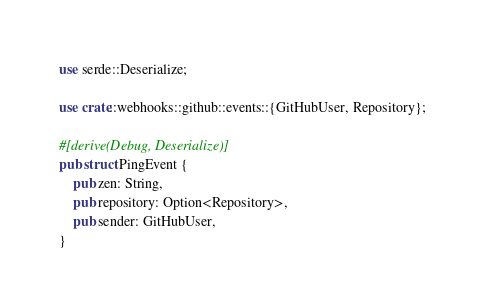<code> <loc_0><loc_0><loc_500><loc_500><_Rust_>use serde::Deserialize;

use crate::webhooks::github::events::{GitHubUser, Repository};

#[derive(Debug, Deserialize)]
pub struct PingEvent {
    pub zen: String,
    pub repository: Option<Repository>,
    pub sender: GitHubUser,
}
</code> 